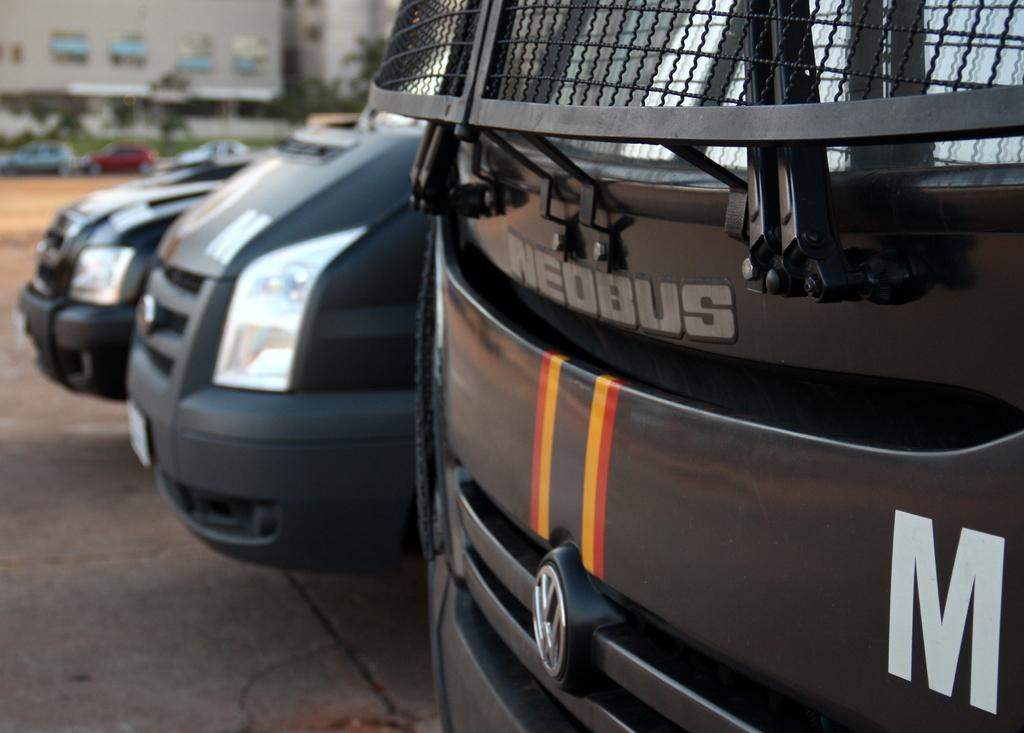What types of objects can be seen in the image? There are vehicles, trees, and buildings in the image. Can you describe the vehicles in the image? The provided facts do not specify the type or number of vehicles in the image. What kind of trees are present in the image? The provided facts do not specify the type of trees in the image. How many buildings can be seen in the image? The provided facts do not specify the number of buildings in the image. What songs are being sung by the laborers in the image? There are no laborers or songs mentioned in the provided facts; the image contains vehicles, trees, and buildings. 